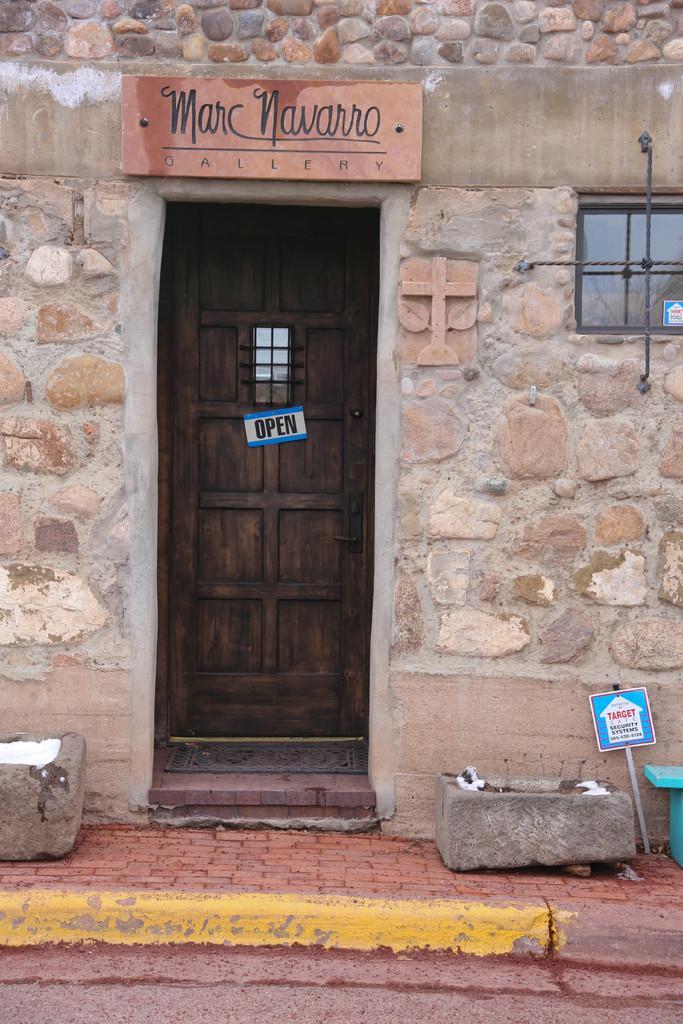Describe this image in one or two sentences. In this image we can see a small board on the door, name board on the wall, window on the right side, mat on the floor, rocks on the footpath, board on a stick and an object. 